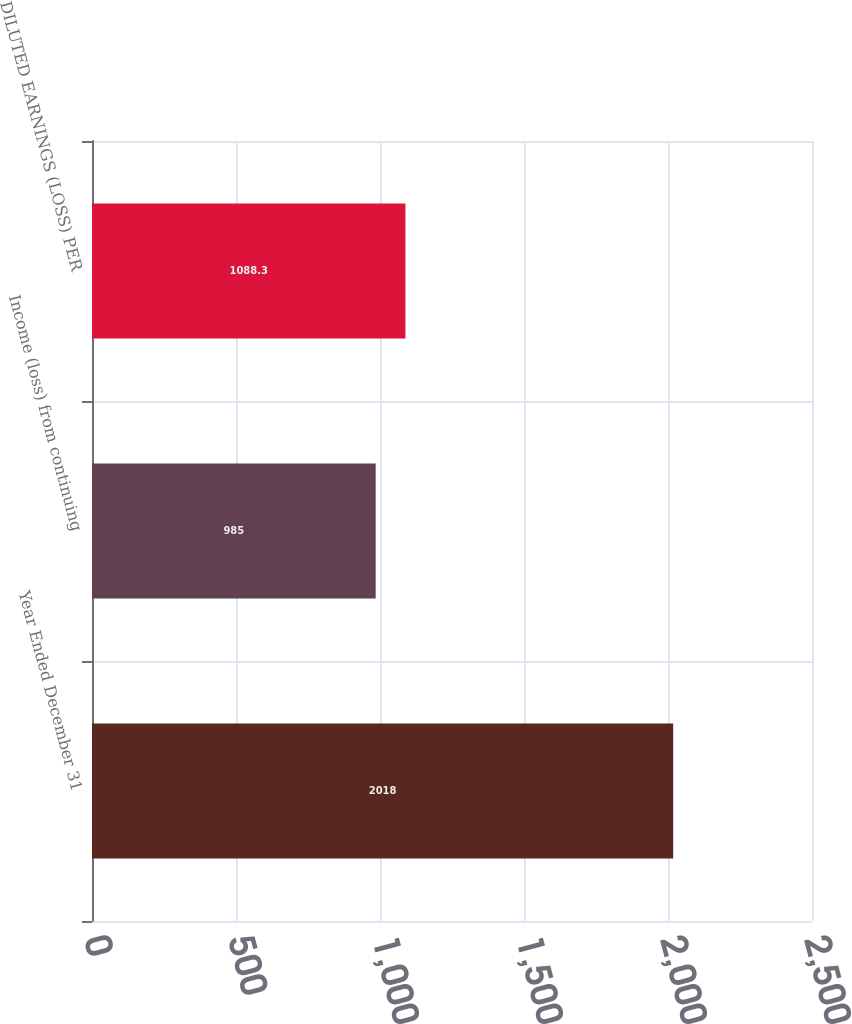Convert chart to OTSL. <chart><loc_0><loc_0><loc_500><loc_500><bar_chart><fcel>Year Ended December 31<fcel>Income (loss) from continuing<fcel>DILUTED EARNINGS (LOSS) PER<nl><fcel>2018<fcel>985<fcel>1088.3<nl></chart> 